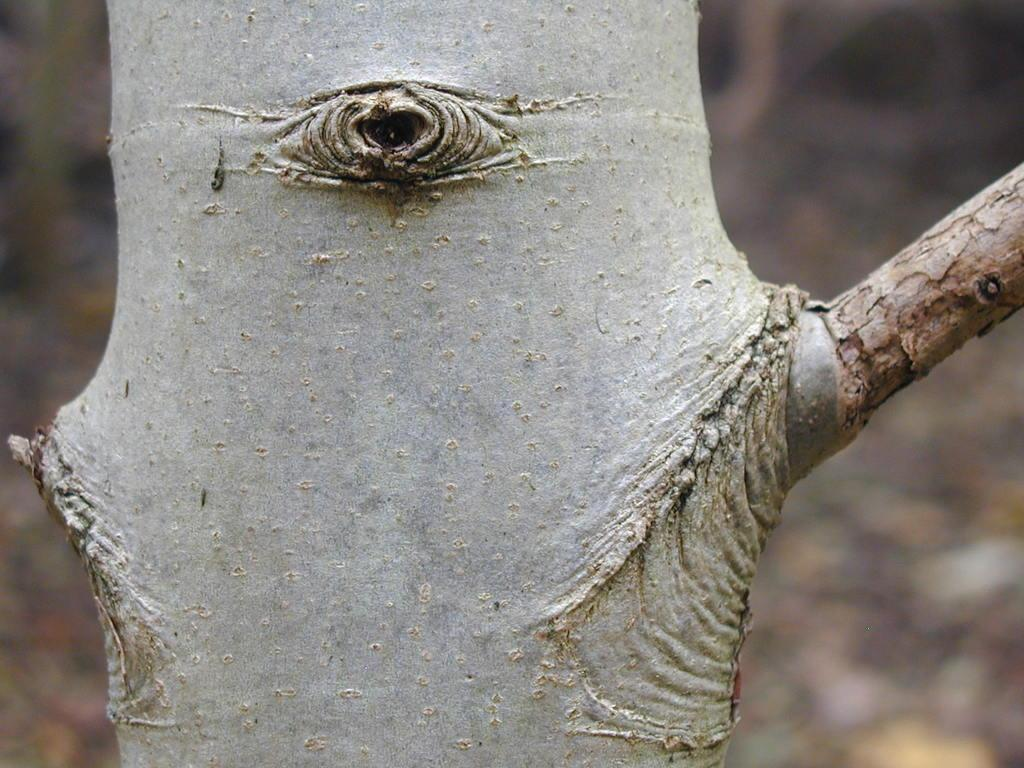What is the main subject in the image? The main subject in the image is a tree trunk. Can you describe the area behind the tree trunk? The area behind the tree trunk is blurry. What type of apparel is hanging on the tree trunk in the image? There is no apparel hanging on the tree trunk in the image. What part of the tree is visible in the image? The image only shows the tree trunk, so no other parts of the tree are visible. 